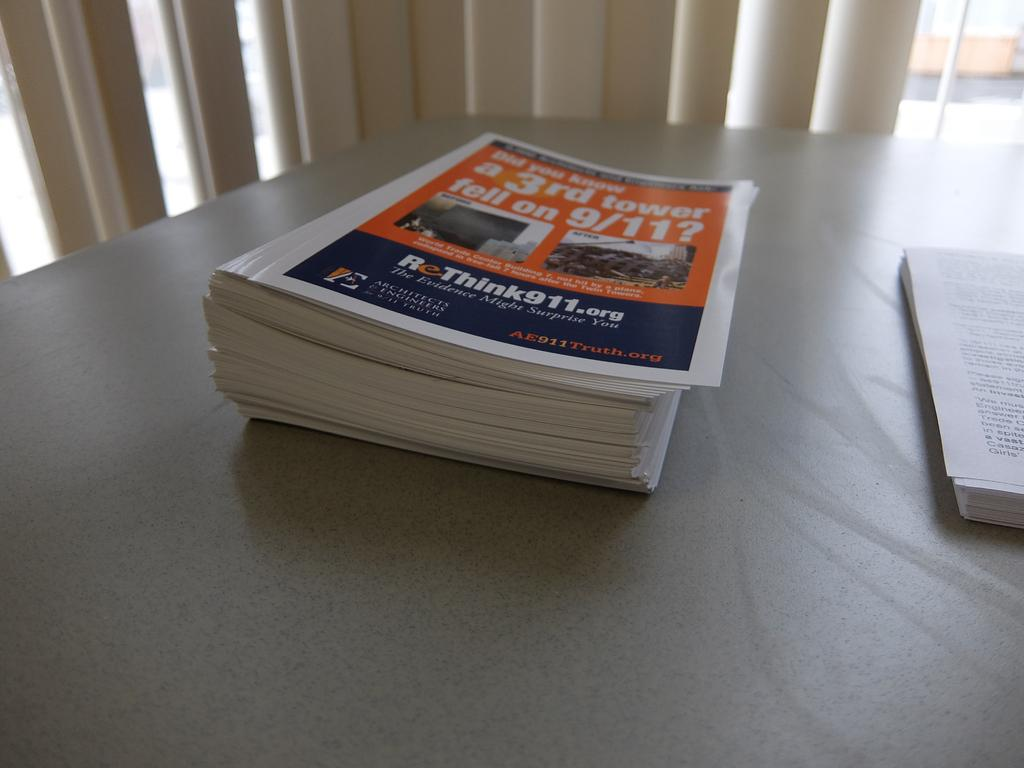<image>
Present a compact description of the photo's key features. Stack of books with Did you know a third tower fell on 9/11 on the front cover. 